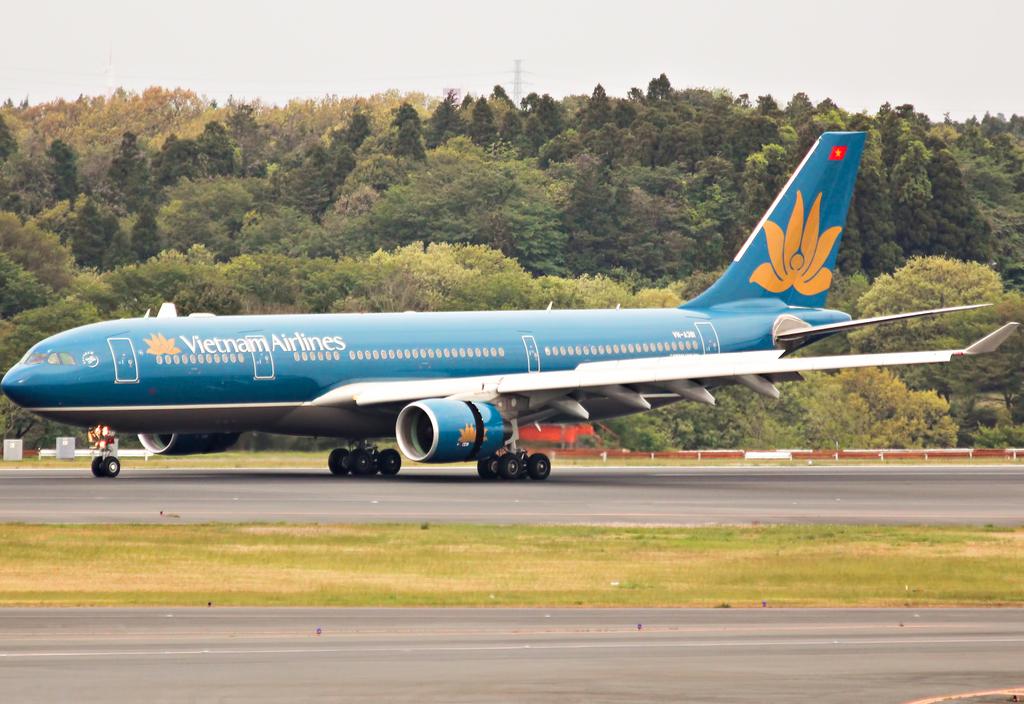What airlines is this?
Provide a succinct answer. Vietnam airlines. What airline is this?
Offer a very short reply. Vietnam airlines. 